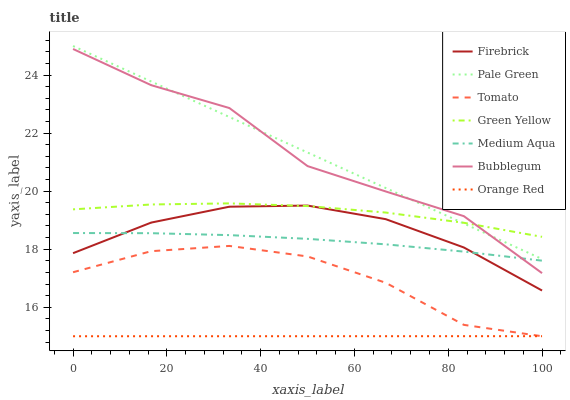Does Orange Red have the minimum area under the curve?
Answer yes or no. Yes. Does Pale Green have the maximum area under the curve?
Answer yes or no. Yes. Does Firebrick have the minimum area under the curve?
Answer yes or no. No. Does Firebrick have the maximum area under the curve?
Answer yes or no. No. Is Pale Green the smoothest?
Answer yes or no. Yes. Is Bubblegum the roughest?
Answer yes or no. Yes. Is Firebrick the smoothest?
Answer yes or no. No. Is Firebrick the roughest?
Answer yes or no. No. Does Tomato have the lowest value?
Answer yes or no. Yes. Does Firebrick have the lowest value?
Answer yes or no. No. Does Pale Green have the highest value?
Answer yes or no. Yes. Does Firebrick have the highest value?
Answer yes or no. No. Is Medium Aqua less than Pale Green?
Answer yes or no. Yes. Is Green Yellow greater than Medium Aqua?
Answer yes or no. Yes. Does Orange Red intersect Tomato?
Answer yes or no. Yes. Is Orange Red less than Tomato?
Answer yes or no. No. Is Orange Red greater than Tomato?
Answer yes or no. No. Does Medium Aqua intersect Pale Green?
Answer yes or no. No. 